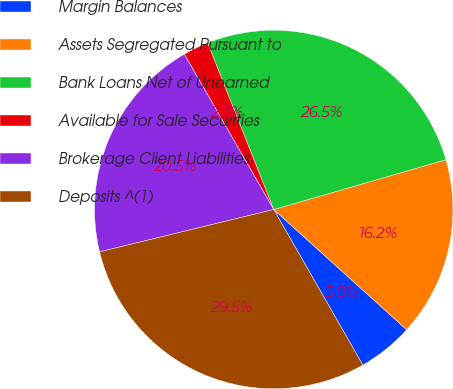Convert chart to OTSL. <chart><loc_0><loc_0><loc_500><loc_500><pie_chart><fcel>Margin Balances<fcel>Assets Segregated Pursuant to<fcel>Bank Loans Net of Unearned<fcel>Available for Sale Securities<fcel>Brokerage Client Liabilities<fcel>Deposits ^(1)<nl><fcel>5.02%<fcel>16.18%<fcel>26.53%<fcel>2.3%<fcel>20.48%<fcel>29.48%<nl></chart> 